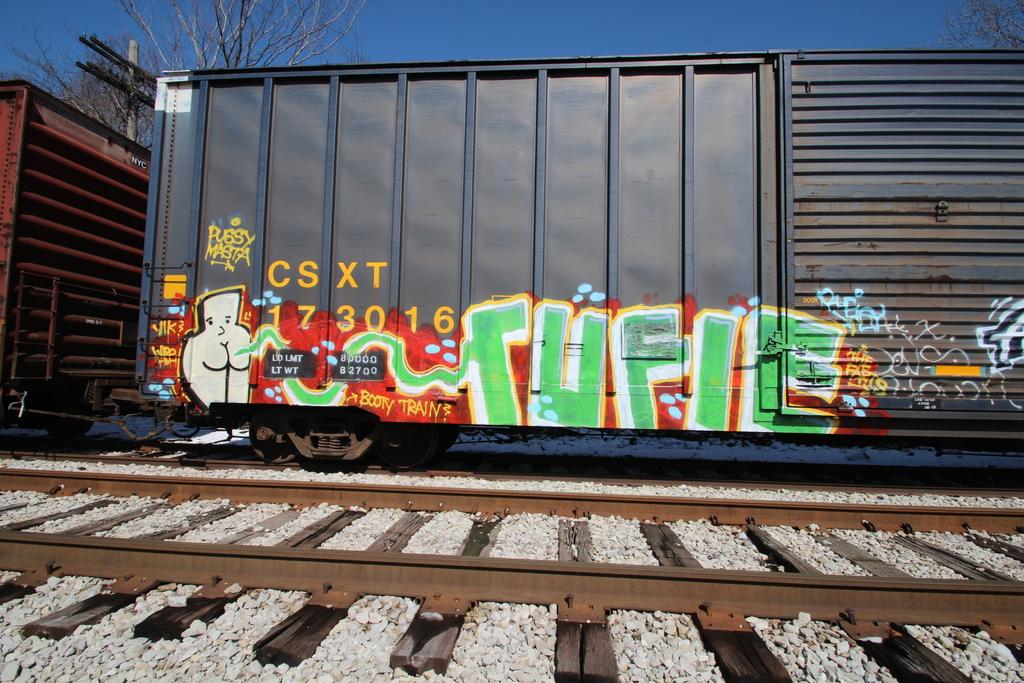<image>
Describe the image concisely. a csxt label on the side of a train 